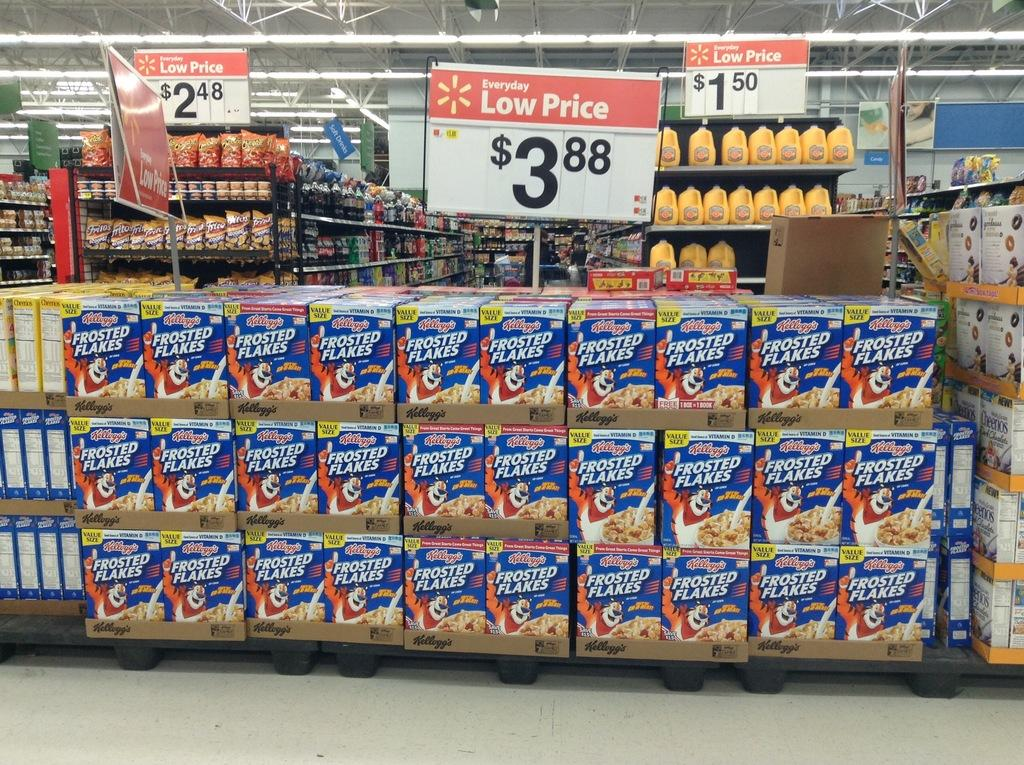<image>
Present a compact description of the photo's key features. A giant display of Kellog's Frosted Flakes is on sale for $3.88. 